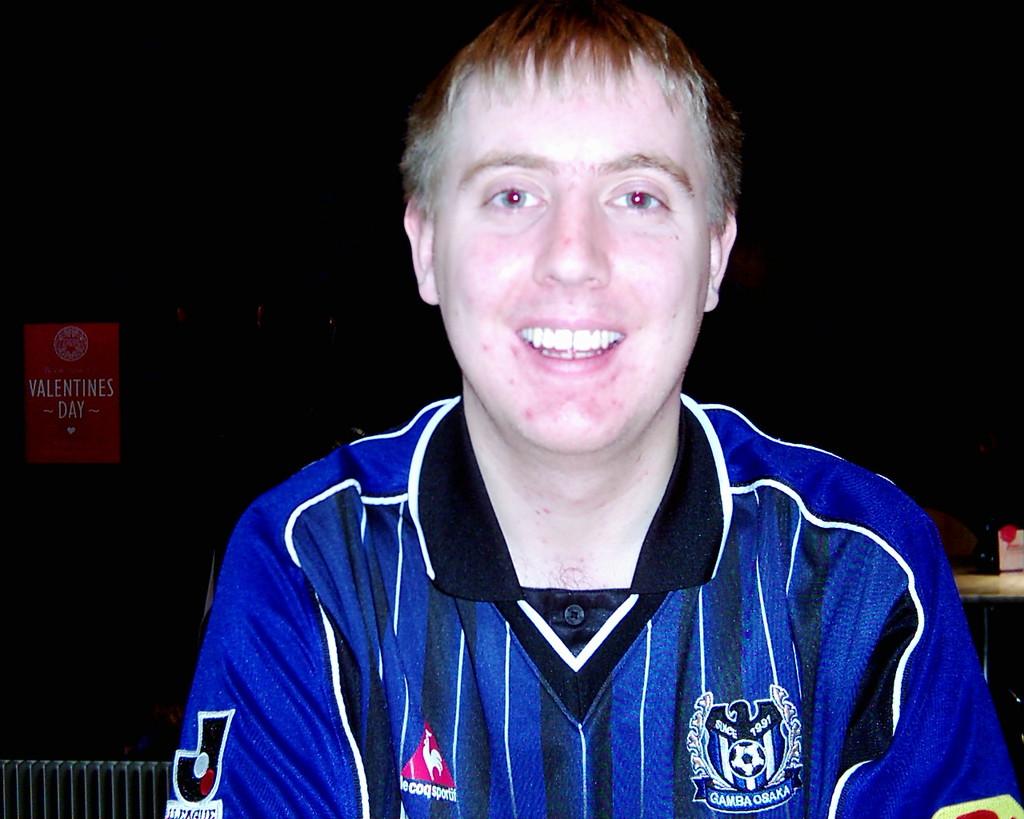What year since?
Offer a very short reply. 1991. 